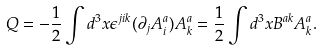<formula> <loc_0><loc_0><loc_500><loc_500>Q = - \frac { 1 } { 2 } \int d ^ { 3 } x \epsilon ^ { j i k } ( \partial _ { j } A _ { i } ^ { a } ) A _ { k } ^ { a } = \frac { 1 } { 2 } \int d ^ { 3 } x B ^ { a k } A _ { k } ^ { a } .</formula> 